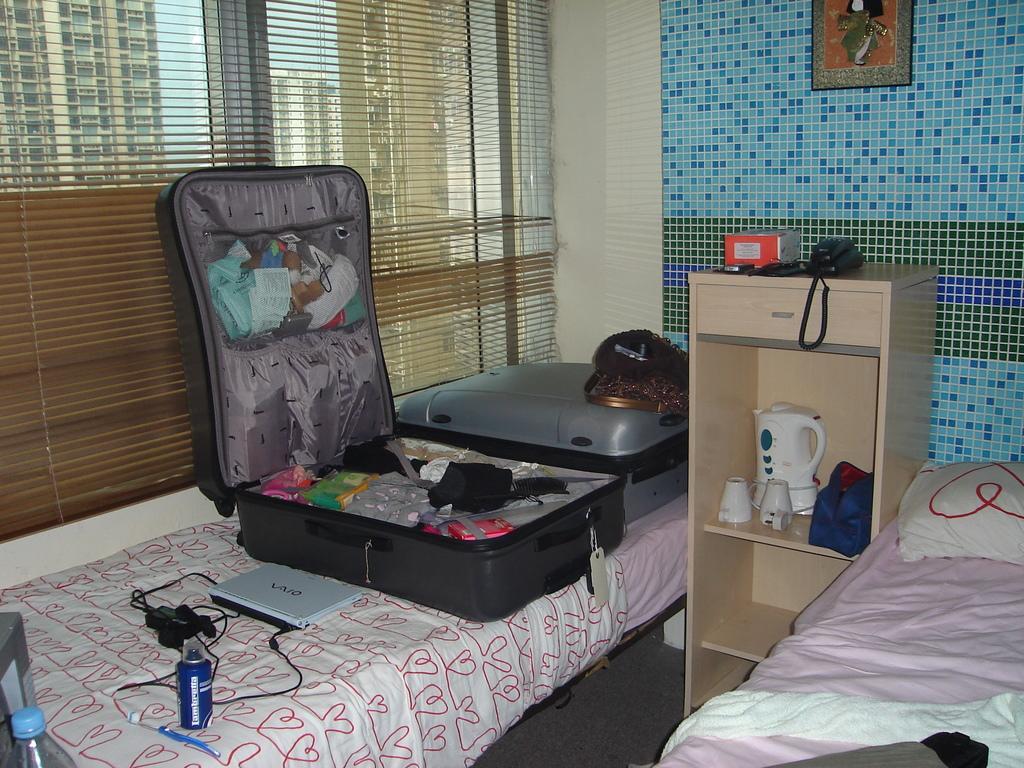Can you describe this image briefly? Here there is a 2 beds and pillow. There are 2 luggage bags. Here we can see laptop, perfume bottle and wires. On the left side, we can see bottle with lid. In the right side, we can see some bag and cups, hot machine. Here we can see telephone, photo frame and blue color tile wall and cream color wall. And the left side, we can see window shades, glass window. Background, we can see buildings. 